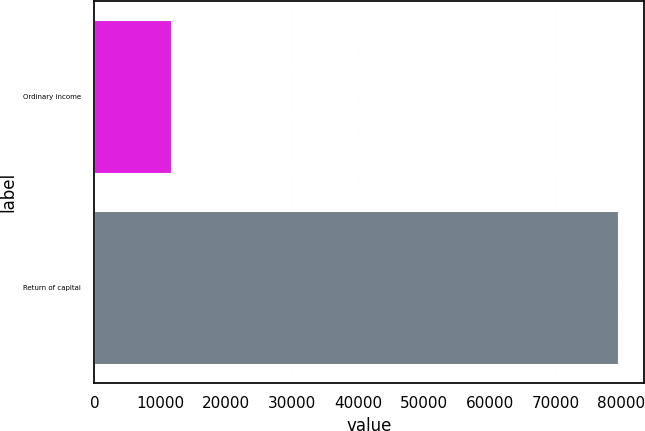Convert chart. <chart><loc_0><loc_0><loc_500><loc_500><bar_chart><fcel>Ordinary income<fcel>Return of capital<nl><fcel>11638<fcel>79445<nl></chart> 